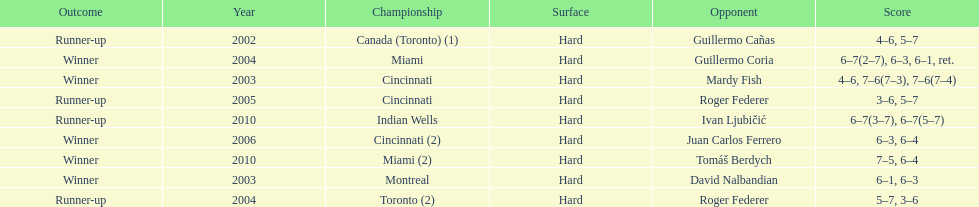How many total wins has he had? 5. 